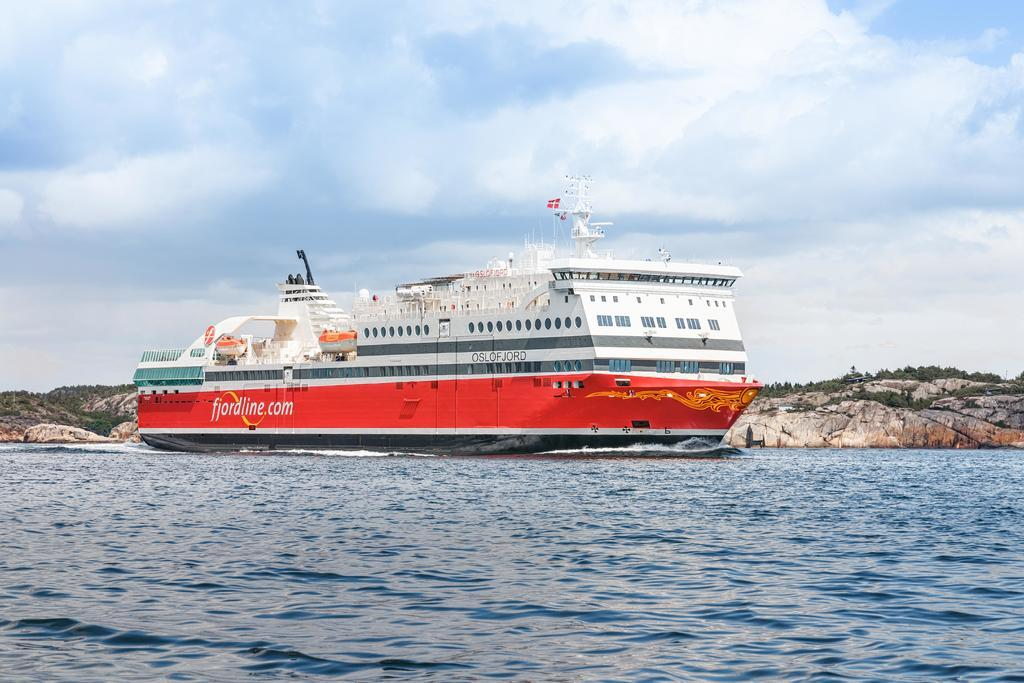What is the main subject of the image? The main subject of the image is a ship. Where is the ship located in the image? The ship is on the water in the image. What can be seen in the background of the image? There are mountains in the background of the image. What is visible at the top of the image? The sky is visible at the top of the image. What type of fruit is hanging from the ship's mast in the image? There is no fruit hanging from the ship's mast in the image. Can you tell me who the guide is for the ship's journey in the image? There is no guide mentioned or depicted in the image. 